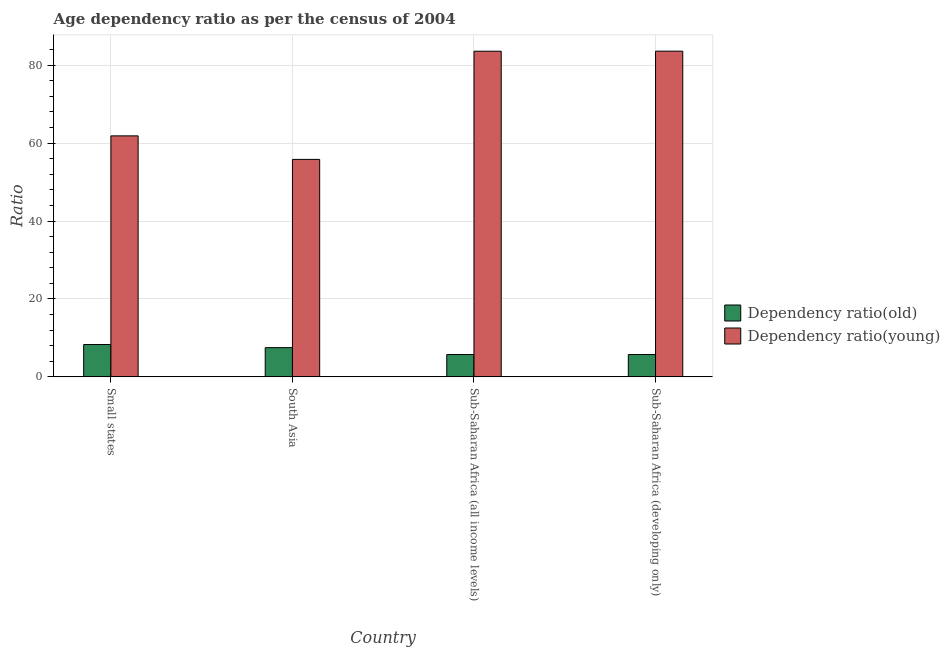How many different coloured bars are there?
Offer a terse response. 2. How many groups of bars are there?
Make the answer very short. 4. Are the number of bars on each tick of the X-axis equal?
Your answer should be compact. Yes. How many bars are there on the 1st tick from the right?
Give a very brief answer. 2. What is the label of the 3rd group of bars from the left?
Ensure brevity in your answer.  Sub-Saharan Africa (all income levels). What is the age dependency ratio(young) in Small states?
Make the answer very short. 61.86. Across all countries, what is the maximum age dependency ratio(young)?
Offer a terse response. 83.6. Across all countries, what is the minimum age dependency ratio(young)?
Offer a terse response. 55.82. In which country was the age dependency ratio(old) maximum?
Your answer should be compact. Small states. In which country was the age dependency ratio(old) minimum?
Your response must be concise. Sub-Saharan Africa (developing only). What is the total age dependency ratio(old) in the graph?
Ensure brevity in your answer.  27.27. What is the difference between the age dependency ratio(young) in Small states and that in Sub-Saharan Africa (all income levels)?
Your answer should be very brief. -21.73. What is the difference between the age dependency ratio(old) in Sub-Saharan Africa (all income levels) and the age dependency ratio(young) in Small states?
Offer a very short reply. -56.12. What is the average age dependency ratio(young) per country?
Provide a short and direct response. 71.22. What is the difference between the age dependency ratio(young) and age dependency ratio(old) in South Asia?
Provide a succinct answer. 48.32. What is the ratio of the age dependency ratio(young) in South Asia to that in Sub-Saharan Africa (developing only)?
Offer a very short reply. 0.67. What is the difference between the highest and the second highest age dependency ratio(young)?
Provide a succinct answer. 0.01. What is the difference between the highest and the lowest age dependency ratio(old)?
Your response must be concise. 2.57. In how many countries, is the age dependency ratio(young) greater than the average age dependency ratio(young) taken over all countries?
Offer a very short reply. 2. What does the 1st bar from the left in Sub-Saharan Africa (all income levels) represents?
Ensure brevity in your answer.  Dependency ratio(old). What does the 1st bar from the right in Sub-Saharan Africa (developing only) represents?
Give a very brief answer. Dependency ratio(young). How many bars are there?
Keep it short and to the point. 8. How many legend labels are there?
Offer a terse response. 2. What is the title of the graph?
Your answer should be compact. Age dependency ratio as per the census of 2004. What is the label or title of the X-axis?
Make the answer very short. Country. What is the label or title of the Y-axis?
Your answer should be very brief. Ratio. What is the Ratio of Dependency ratio(old) in Small states?
Make the answer very short. 8.3. What is the Ratio of Dependency ratio(young) in Small states?
Your answer should be compact. 61.86. What is the Ratio in Dependency ratio(old) in South Asia?
Your answer should be compact. 7.5. What is the Ratio of Dependency ratio(young) in South Asia?
Your response must be concise. 55.82. What is the Ratio in Dependency ratio(old) in Sub-Saharan Africa (all income levels)?
Keep it short and to the point. 5.73. What is the Ratio of Dependency ratio(young) in Sub-Saharan Africa (all income levels)?
Make the answer very short. 83.59. What is the Ratio in Dependency ratio(old) in Sub-Saharan Africa (developing only)?
Offer a very short reply. 5.73. What is the Ratio in Dependency ratio(young) in Sub-Saharan Africa (developing only)?
Provide a short and direct response. 83.6. Across all countries, what is the maximum Ratio of Dependency ratio(old)?
Provide a succinct answer. 8.3. Across all countries, what is the maximum Ratio in Dependency ratio(young)?
Your answer should be very brief. 83.6. Across all countries, what is the minimum Ratio in Dependency ratio(old)?
Provide a short and direct response. 5.73. Across all countries, what is the minimum Ratio of Dependency ratio(young)?
Provide a succinct answer. 55.82. What is the total Ratio of Dependency ratio(old) in the graph?
Give a very brief answer. 27.27. What is the total Ratio of Dependency ratio(young) in the graph?
Your answer should be compact. 284.86. What is the difference between the Ratio of Dependency ratio(old) in Small states and that in South Asia?
Your answer should be compact. 0.8. What is the difference between the Ratio in Dependency ratio(young) in Small states and that in South Asia?
Give a very brief answer. 6.04. What is the difference between the Ratio in Dependency ratio(old) in Small states and that in Sub-Saharan Africa (all income levels)?
Your answer should be compact. 2.57. What is the difference between the Ratio in Dependency ratio(young) in Small states and that in Sub-Saharan Africa (all income levels)?
Offer a terse response. -21.73. What is the difference between the Ratio of Dependency ratio(old) in Small states and that in Sub-Saharan Africa (developing only)?
Give a very brief answer. 2.57. What is the difference between the Ratio in Dependency ratio(young) in Small states and that in Sub-Saharan Africa (developing only)?
Offer a terse response. -21.74. What is the difference between the Ratio in Dependency ratio(old) in South Asia and that in Sub-Saharan Africa (all income levels)?
Keep it short and to the point. 1.77. What is the difference between the Ratio in Dependency ratio(young) in South Asia and that in Sub-Saharan Africa (all income levels)?
Your answer should be compact. -27.77. What is the difference between the Ratio in Dependency ratio(old) in South Asia and that in Sub-Saharan Africa (developing only)?
Offer a terse response. 1.77. What is the difference between the Ratio of Dependency ratio(young) in South Asia and that in Sub-Saharan Africa (developing only)?
Give a very brief answer. -27.78. What is the difference between the Ratio of Dependency ratio(old) in Sub-Saharan Africa (all income levels) and that in Sub-Saharan Africa (developing only)?
Offer a very short reply. 0. What is the difference between the Ratio in Dependency ratio(young) in Sub-Saharan Africa (all income levels) and that in Sub-Saharan Africa (developing only)?
Offer a terse response. -0.01. What is the difference between the Ratio in Dependency ratio(old) in Small states and the Ratio in Dependency ratio(young) in South Asia?
Offer a terse response. -47.52. What is the difference between the Ratio of Dependency ratio(old) in Small states and the Ratio of Dependency ratio(young) in Sub-Saharan Africa (all income levels)?
Provide a short and direct response. -75.28. What is the difference between the Ratio of Dependency ratio(old) in Small states and the Ratio of Dependency ratio(young) in Sub-Saharan Africa (developing only)?
Make the answer very short. -75.3. What is the difference between the Ratio in Dependency ratio(old) in South Asia and the Ratio in Dependency ratio(young) in Sub-Saharan Africa (all income levels)?
Offer a terse response. -76.08. What is the difference between the Ratio of Dependency ratio(old) in South Asia and the Ratio of Dependency ratio(young) in Sub-Saharan Africa (developing only)?
Your answer should be very brief. -76.1. What is the difference between the Ratio in Dependency ratio(old) in Sub-Saharan Africa (all income levels) and the Ratio in Dependency ratio(young) in Sub-Saharan Africa (developing only)?
Make the answer very short. -77.86. What is the average Ratio in Dependency ratio(old) per country?
Your answer should be very brief. 6.82. What is the average Ratio of Dependency ratio(young) per country?
Provide a succinct answer. 71.22. What is the difference between the Ratio of Dependency ratio(old) and Ratio of Dependency ratio(young) in Small states?
Give a very brief answer. -53.55. What is the difference between the Ratio of Dependency ratio(old) and Ratio of Dependency ratio(young) in South Asia?
Make the answer very short. -48.32. What is the difference between the Ratio in Dependency ratio(old) and Ratio in Dependency ratio(young) in Sub-Saharan Africa (all income levels)?
Your response must be concise. -77.85. What is the difference between the Ratio in Dependency ratio(old) and Ratio in Dependency ratio(young) in Sub-Saharan Africa (developing only)?
Provide a succinct answer. -77.87. What is the ratio of the Ratio of Dependency ratio(old) in Small states to that in South Asia?
Provide a short and direct response. 1.11. What is the ratio of the Ratio in Dependency ratio(young) in Small states to that in South Asia?
Your answer should be very brief. 1.11. What is the ratio of the Ratio of Dependency ratio(old) in Small states to that in Sub-Saharan Africa (all income levels)?
Give a very brief answer. 1.45. What is the ratio of the Ratio in Dependency ratio(young) in Small states to that in Sub-Saharan Africa (all income levels)?
Offer a very short reply. 0.74. What is the ratio of the Ratio in Dependency ratio(old) in Small states to that in Sub-Saharan Africa (developing only)?
Keep it short and to the point. 1.45. What is the ratio of the Ratio in Dependency ratio(young) in Small states to that in Sub-Saharan Africa (developing only)?
Offer a terse response. 0.74. What is the ratio of the Ratio of Dependency ratio(old) in South Asia to that in Sub-Saharan Africa (all income levels)?
Your answer should be very brief. 1.31. What is the ratio of the Ratio in Dependency ratio(young) in South Asia to that in Sub-Saharan Africa (all income levels)?
Make the answer very short. 0.67. What is the ratio of the Ratio in Dependency ratio(old) in South Asia to that in Sub-Saharan Africa (developing only)?
Provide a short and direct response. 1.31. What is the ratio of the Ratio of Dependency ratio(young) in South Asia to that in Sub-Saharan Africa (developing only)?
Provide a short and direct response. 0.67. What is the ratio of the Ratio in Dependency ratio(old) in Sub-Saharan Africa (all income levels) to that in Sub-Saharan Africa (developing only)?
Ensure brevity in your answer.  1. What is the difference between the highest and the second highest Ratio of Dependency ratio(old)?
Offer a very short reply. 0.8. What is the difference between the highest and the second highest Ratio in Dependency ratio(young)?
Ensure brevity in your answer.  0.01. What is the difference between the highest and the lowest Ratio of Dependency ratio(old)?
Offer a very short reply. 2.57. What is the difference between the highest and the lowest Ratio of Dependency ratio(young)?
Provide a succinct answer. 27.78. 